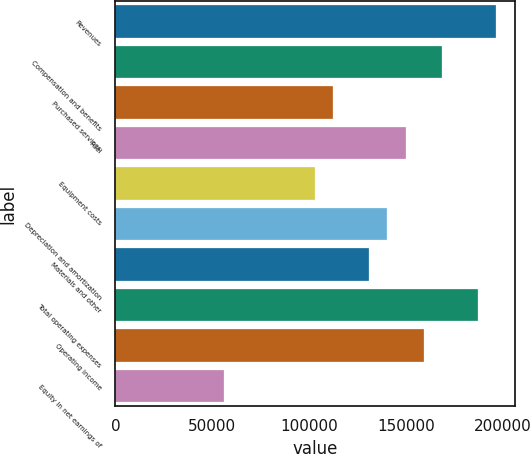Convert chart. <chart><loc_0><loc_0><loc_500><loc_500><bar_chart><fcel>Revenues<fcel>Compensation and benefits<fcel>Purchased services<fcel>Fuel<fcel>Equipment costs<fcel>Depreciation and amortization<fcel>Materials and other<fcel>Total operating expenses<fcel>Operating income<fcel>Equity in net earnings of<nl><fcel>196662<fcel>168568<fcel>112379<fcel>149838<fcel>103014<fcel>140473<fcel>131108<fcel>187297<fcel>159203<fcel>56189.6<nl></chart> 